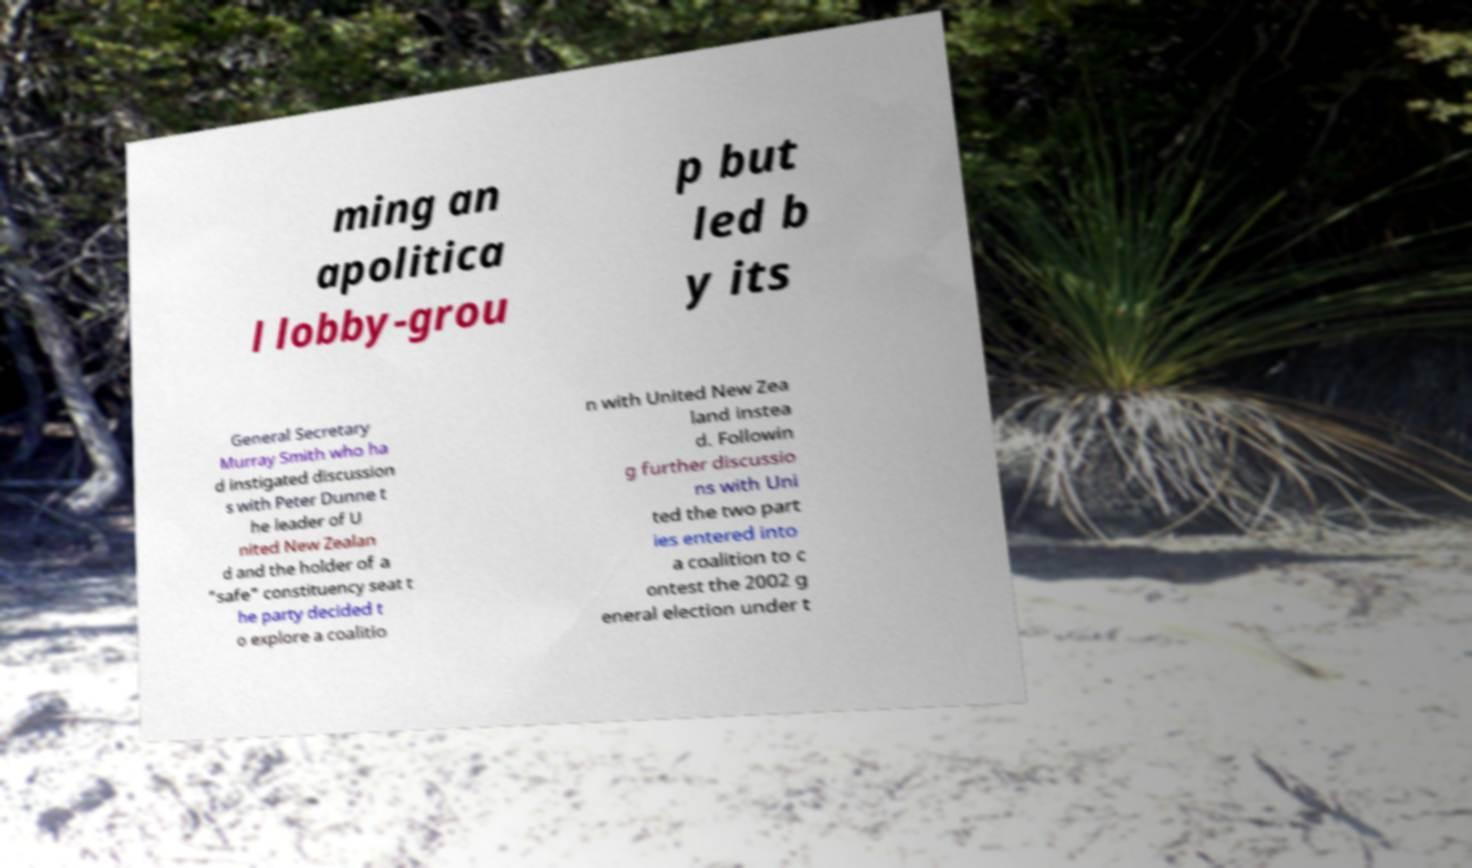I need the written content from this picture converted into text. Can you do that? ming an apolitica l lobby-grou p but led b y its General Secretary Murray Smith who ha d instigated discussion s with Peter Dunne t he leader of U nited New Zealan d and the holder of a "safe" constituency seat t he party decided t o explore a coalitio n with United New Zea land instea d. Followin g further discussio ns with Uni ted the two part ies entered into a coalition to c ontest the 2002 g eneral election under t 